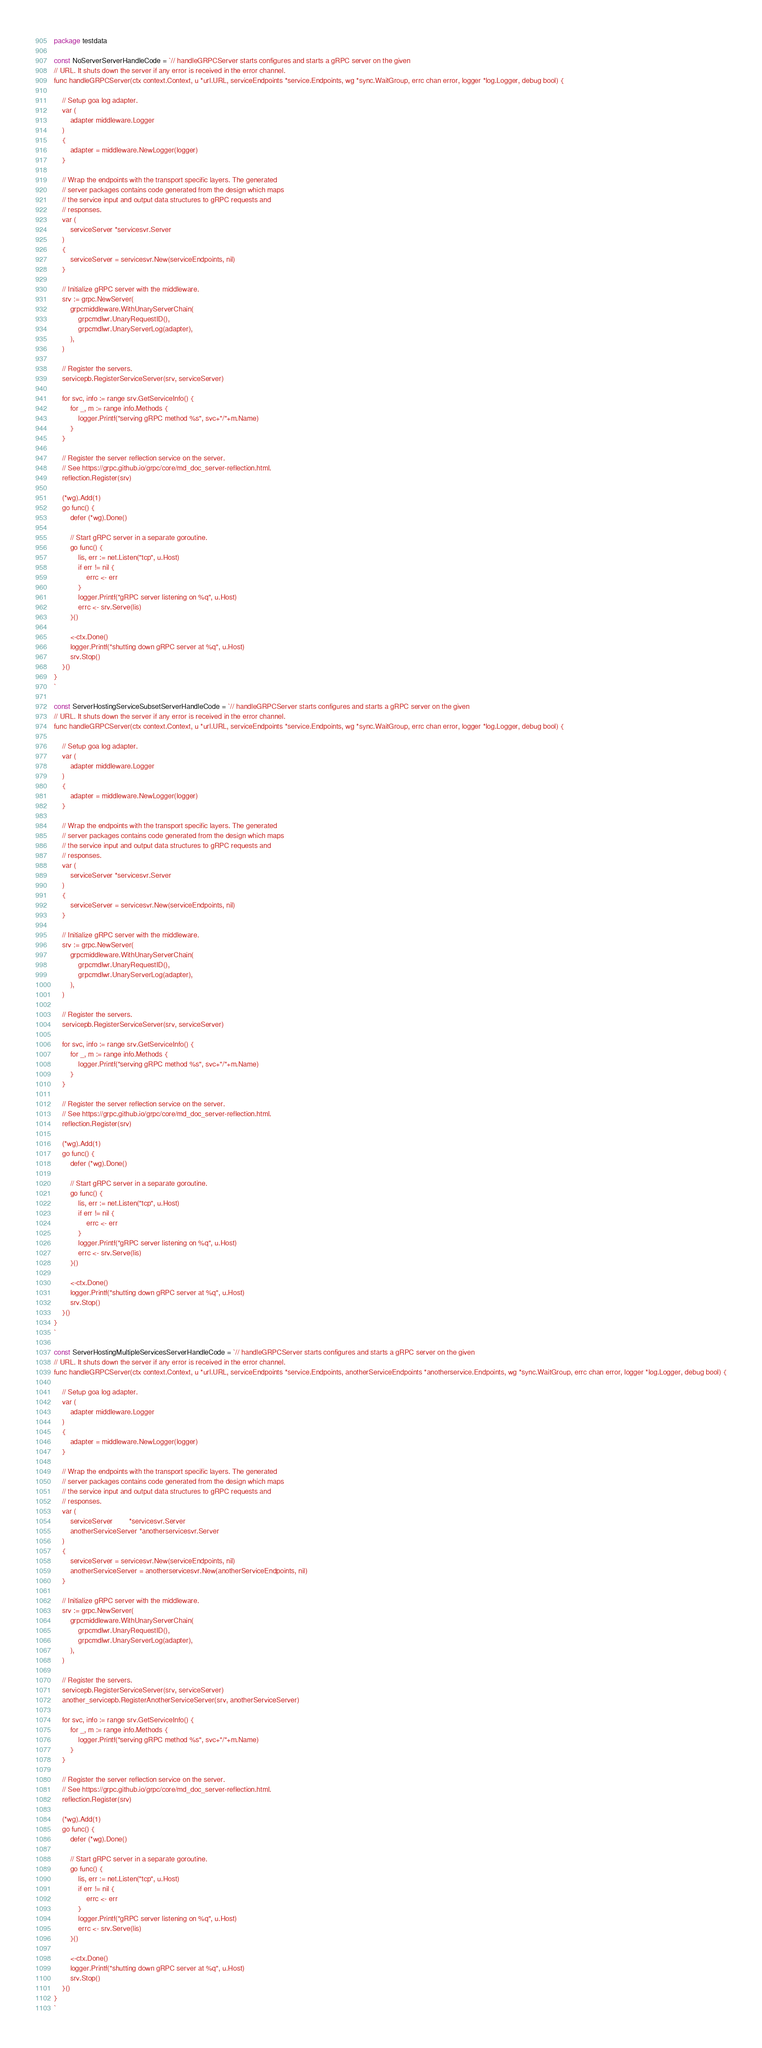Convert code to text. <code><loc_0><loc_0><loc_500><loc_500><_Go_>package testdata

const NoServerServerHandleCode = `// handleGRPCServer starts configures and starts a gRPC server on the given
// URL. It shuts down the server if any error is received in the error channel.
func handleGRPCServer(ctx context.Context, u *url.URL, serviceEndpoints *service.Endpoints, wg *sync.WaitGroup, errc chan error, logger *log.Logger, debug bool) {

	// Setup goa log adapter.
	var (
		adapter middleware.Logger
	)
	{
		adapter = middleware.NewLogger(logger)
	}

	// Wrap the endpoints with the transport specific layers. The generated
	// server packages contains code generated from the design which maps
	// the service input and output data structures to gRPC requests and
	// responses.
	var (
		serviceServer *servicesvr.Server
	)
	{
		serviceServer = servicesvr.New(serviceEndpoints, nil)
	}

	// Initialize gRPC server with the middleware.
	srv := grpc.NewServer(
		grpcmiddleware.WithUnaryServerChain(
			grpcmdlwr.UnaryRequestID(),
			grpcmdlwr.UnaryServerLog(adapter),
		),
	)

	// Register the servers.
	servicepb.RegisterServiceServer(srv, serviceServer)

	for svc, info := range srv.GetServiceInfo() {
		for _, m := range info.Methods {
			logger.Printf("serving gRPC method %s", svc+"/"+m.Name)
		}
	}

	// Register the server reflection service on the server.
	// See https://grpc.github.io/grpc/core/md_doc_server-reflection.html.
	reflection.Register(srv)

	(*wg).Add(1)
	go func() {
		defer (*wg).Done()

		// Start gRPC server in a separate goroutine.
		go func() {
			lis, err := net.Listen("tcp", u.Host)
			if err != nil {
				errc <- err
			}
			logger.Printf("gRPC server listening on %q", u.Host)
			errc <- srv.Serve(lis)
		}()

		<-ctx.Done()
		logger.Printf("shutting down gRPC server at %q", u.Host)
		srv.Stop()
	}()
}
`

const ServerHostingServiceSubsetServerHandleCode = `// handleGRPCServer starts configures and starts a gRPC server on the given
// URL. It shuts down the server if any error is received in the error channel.
func handleGRPCServer(ctx context.Context, u *url.URL, serviceEndpoints *service.Endpoints, wg *sync.WaitGroup, errc chan error, logger *log.Logger, debug bool) {

	// Setup goa log adapter.
	var (
		adapter middleware.Logger
	)
	{
		adapter = middleware.NewLogger(logger)
	}

	// Wrap the endpoints with the transport specific layers. The generated
	// server packages contains code generated from the design which maps
	// the service input and output data structures to gRPC requests and
	// responses.
	var (
		serviceServer *servicesvr.Server
	)
	{
		serviceServer = servicesvr.New(serviceEndpoints, nil)
	}

	// Initialize gRPC server with the middleware.
	srv := grpc.NewServer(
		grpcmiddleware.WithUnaryServerChain(
			grpcmdlwr.UnaryRequestID(),
			grpcmdlwr.UnaryServerLog(adapter),
		),
	)

	// Register the servers.
	servicepb.RegisterServiceServer(srv, serviceServer)

	for svc, info := range srv.GetServiceInfo() {
		for _, m := range info.Methods {
			logger.Printf("serving gRPC method %s", svc+"/"+m.Name)
		}
	}

	// Register the server reflection service on the server.
	// See https://grpc.github.io/grpc/core/md_doc_server-reflection.html.
	reflection.Register(srv)

	(*wg).Add(1)
	go func() {
		defer (*wg).Done()

		// Start gRPC server in a separate goroutine.
		go func() {
			lis, err := net.Listen("tcp", u.Host)
			if err != nil {
				errc <- err
			}
			logger.Printf("gRPC server listening on %q", u.Host)
			errc <- srv.Serve(lis)
		}()

		<-ctx.Done()
		logger.Printf("shutting down gRPC server at %q", u.Host)
		srv.Stop()
	}()
}
`

const ServerHostingMultipleServicesServerHandleCode = `// handleGRPCServer starts configures and starts a gRPC server on the given
// URL. It shuts down the server if any error is received in the error channel.
func handleGRPCServer(ctx context.Context, u *url.URL, serviceEndpoints *service.Endpoints, anotherServiceEndpoints *anotherservice.Endpoints, wg *sync.WaitGroup, errc chan error, logger *log.Logger, debug bool) {

	// Setup goa log adapter.
	var (
		adapter middleware.Logger
	)
	{
		adapter = middleware.NewLogger(logger)
	}

	// Wrap the endpoints with the transport specific layers. The generated
	// server packages contains code generated from the design which maps
	// the service input and output data structures to gRPC requests and
	// responses.
	var (
		serviceServer        *servicesvr.Server
		anotherServiceServer *anotherservicesvr.Server
	)
	{
		serviceServer = servicesvr.New(serviceEndpoints, nil)
		anotherServiceServer = anotherservicesvr.New(anotherServiceEndpoints, nil)
	}

	// Initialize gRPC server with the middleware.
	srv := grpc.NewServer(
		grpcmiddleware.WithUnaryServerChain(
			grpcmdlwr.UnaryRequestID(),
			grpcmdlwr.UnaryServerLog(adapter),
		),
	)

	// Register the servers.
	servicepb.RegisterServiceServer(srv, serviceServer)
	another_servicepb.RegisterAnotherServiceServer(srv, anotherServiceServer)

	for svc, info := range srv.GetServiceInfo() {
		for _, m := range info.Methods {
			logger.Printf("serving gRPC method %s", svc+"/"+m.Name)
		}
	}

	// Register the server reflection service on the server.
	// See https://grpc.github.io/grpc/core/md_doc_server-reflection.html.
	reflection.Register(srv)

	(*wg).Add(1)
	go func() {
		defer (*wg).Done()

		// Start gRPC server in a separate goroutine.
		go func() {
			lis, err := net.Listen("tcp", u.Host)
			if err != nil {
				errc <- err
			}
			logger.Printf("gRPC server listening on %q", u.Host)
			errc <- srv.Serve(lis)
		}()

		<-ctx.Done()
		logger.Printf("shutting down gRPC server at %q", u.Host)
		srv.Stop()
	}()
}
`
</code> 